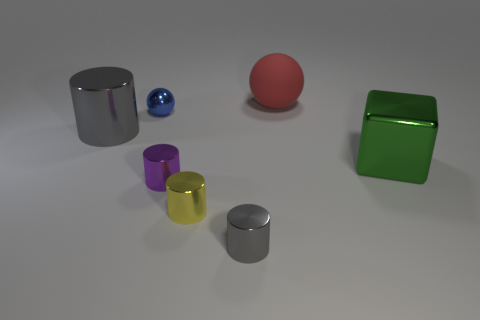What can you tell me about the lighting and shadows in this scene? The scene is softly illuminated from above, casting gentle, diffuse shadows that gracefully stretch away from the objects. The light source, likely positioned out of frame, gives the scene a calm, almost serene ambiance, highlighting the textures and reflective qualities of the objects. 